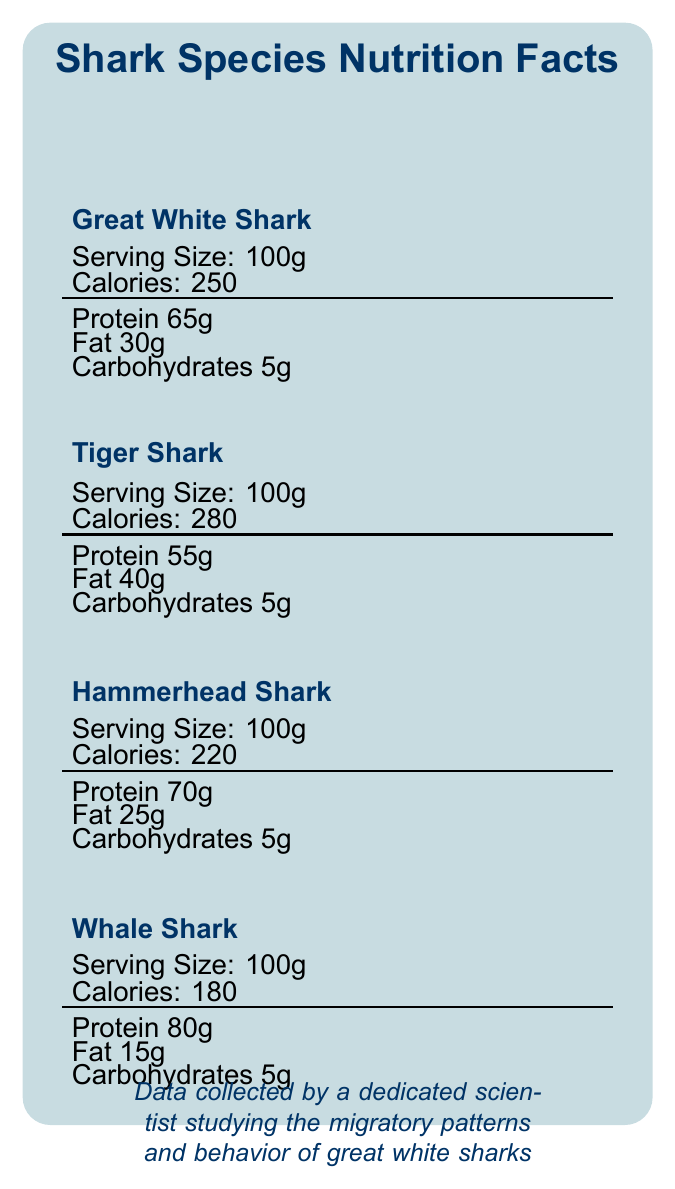What is the serving size for each shark species mentioned? The serving size mentioned for all shark species in the document is 100g.
Answer: 100g Which shark species has the highest calorie content per serving? The nutrient facts indicate that the Tiger Shark has 280 calories per serving, which is the highest among the listed sharks.
Answer: Tiger Shark Which shark species has the highest protein content? A. Great White Shark B. Hammerhead Shark C. Whale Shark D. Tiger Shark The Whale Shark has 80g of protein per serving, which is the highest among the listed sharks.
Answer: C. Whale Shark What is the main prey item common between the diets of Great White and Whale Shark? Both Great White Shark and Whale Shark have squid listed as one of their primary prey items.
Answer: Squid True/False: The Hammerhead Shark's diet is highest in carbohydrates. Each shark species' diet has 5g of carbohydrates per serving, so the Hammerhead Shark's diet is not highest in carbohydrates.
Answer: False How does the fat content of the Tiger Shark's diet support its lifestyle? The Tiger Shark's higher fat content helps with buoyancy control and energy storage in its varied habitats.
Answer: For buoyancy control and energy storage in varied habitats Which shark species has the lowest fat content? A. Great White Shark B. Hammerhead Shark C. Whale Shark D. Tiger Shark The Whale Shark has 15g of fat per serving, which is the lowest among the listed sharks.
Answer: C. Whale Shark Summarize the main idea of the document. The document focuses on comparing the diets of Great White Shark, Tiger Shark, Hammerhead Shark, and Whale Shark, detailing their nutritional content, prey items, and how these diets support their specific lifestyles and behaviors.
Answer: The document provides a comparative analysis of the nutritional content of the diets of four shark species. It includes information on the protein, fat, carbohydrates, calories per serving, primary prey items, dietary adaptations, and research implications. Can you determine the total daily calorie intake for a Great White Shark from the document? The document only provides calorie information per 100g serving but does not specify the total daily intake or the number of servings consumed daily.
Answer: Not enough information How does the diet of the Hammerhead Shark support its hunting techniques? The balanced protein-fat ratio in the Hammerhead Shark's diet supports its agility and specialized hunting techniques.
Answer: Balanced protein-fat ratio for agile swimming and specialized hunting techniques How many calories are there in the diet of the Whale Shark per serving? According to the document, the Whale Shark's diet contains 180 calories per 100g serving.
Answer: 180 calories What types of prey do Great White Sharks primarily consume? The document lists seals, sea lions, tuna, and dolphins as the primary prey items for Great White Sharks.
Answer: Seals, Sea lions, Tuna, Dolphins 